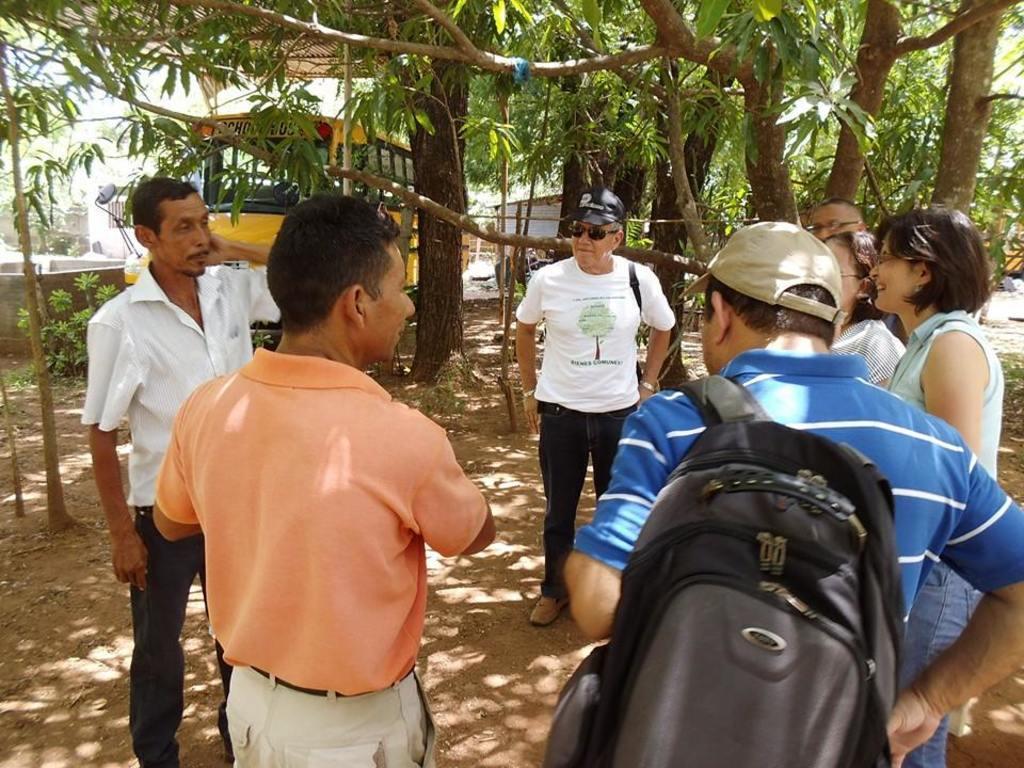Describe this image in one or two sentences. In this image I can see a person wearing blue t shirt and black bag and another person wearing orange t shirt and white colored pant are standing on the ground. In the background I can see few other persons are standing on the ground, few trees which are green and brown in color, a yellow colored vehicle and few buildings. 